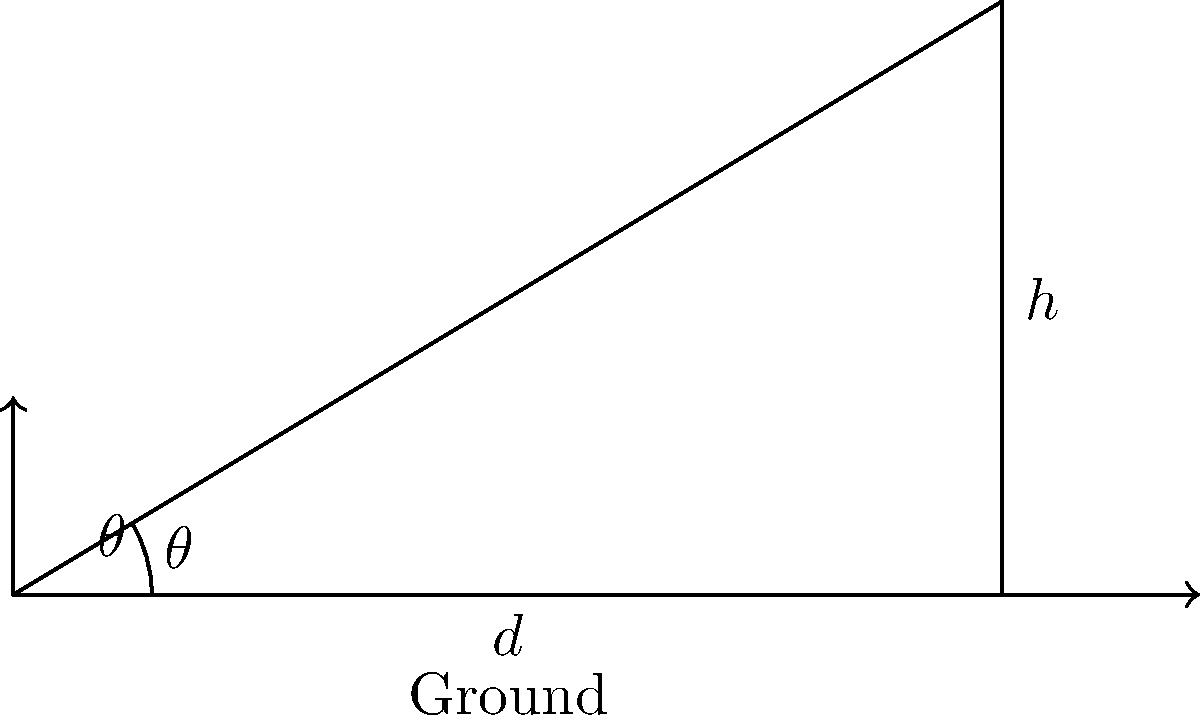A hijabi athlete is practicing javelin throw. She releases the javelin at a height of 2 meters and wants it to land 40 meters away. If the javelin's trajectory forms a parabola and reaches a maximum height of 8 meters, what is the launch angle $\theta$ (in degrees) that allows her to achieve this while maintaining her modest attire? Let's approach this step-by-step:

1) In a parabolic trajectory, the horizontal distance $d$ is given by:
   $$d = \frac{v_0^2 \sin(2\theta)}{g}$$
   where $v_0$ is the initial velocity, $\theta$ is the launch angle, and $g$ is the acceleration due to gravity (9.8 m/s²).

2) The maximum height $h$ reached by the javelin is given by:
   $$h = \frac{v_0^2 \sin^2(\theta)}{2g} + h_0$$
   where $h_0$ is the initial height (2 meters in this case).

3) We know that $d = 40$ m and $h = 8$ m. Let's substitute these values:
   $$40 = \frac{v_0^2 \sin(2\theta)}{9.8}$$
   $$8 = \frac{v_0^2 \sin^2(\theta)}{2(9.8)} + 2$$

4) From the second equation:
   $$6 = \frac{v_0^2 \sin^2(\theta)}{19.6}$$
   $$v_0^2 \sin^2(\theta) = 117.6$$

5) Substituting this into the first equation:
   $$40 = \frac{117.6}{\sin^2(\theta)} \cdot \frac{\sin(2\theta)}{9.8}$$

6) Simplifying:
   $$40 = \frac{117.6}{9.8} \cdot \frac{\sin(2\theta)}{\sin^2(\theta)} = 12 \cdot \frac{2\sin(\theta)\cos(\theta)}{\sin^2(\theta)} = 24 \cdot \frac{\cos(\theta)}{\sin(\theta)}$$

7) Therefore:
   $$\tan(\theta) = \frac{24}{40} = 0.6$$

8) Taking the inverse tangent:
   $$\theta = \tan^{-1}(0.6) \approx 30.96^\circ$$

Thus, the launch angle should be approximately 31 degrees.
Answer: $31^\circ$ 